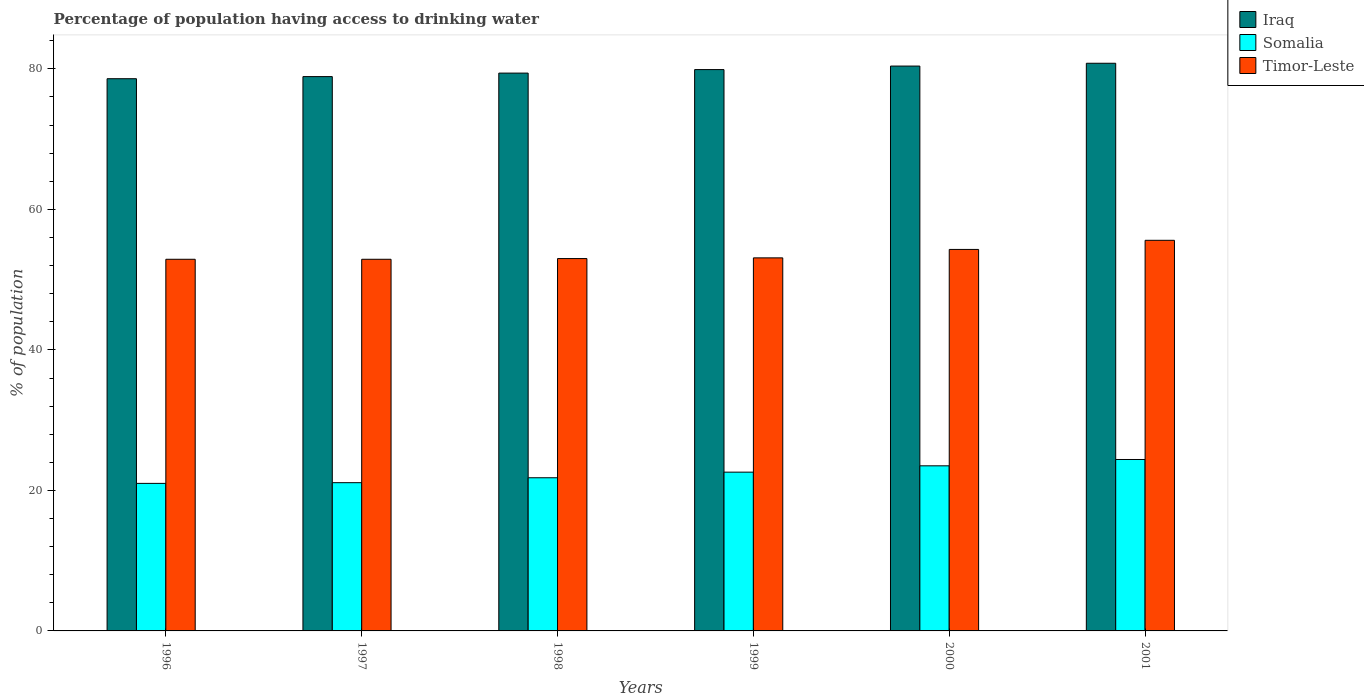How many different coloured bars are there?
Give a very brief answer. 3. How many groups of bars are there?
Ensure brevity in your answer.  6. How many bars are there on the 4th tick from the left?
Make the answer very short. 3. How many bars are there on the 1st tick from the right?
Offer a very short reply. 3. What is the percentage of population having access to drinking water in Somalia in 1998?
Your answer should be compact. 21.8. Across all years, what is the maximum percentage of population having access to drinking water in Iraq?
Offer a very short reply. 80.8. Across all years, what is the minimum percentage of population having access to drinking water in Timor-Leste?
Your answer should be very brief. 52.9. In which year was the percentage of population having access to drinking water in Timor-Leste maximum?
Give a very brief answer. 2001. What is the total percentage of population having access to drinking water in Somalia in the graph?
Offer a very short reply. 134.4. What is the difference between the percentage of population having access to drinking water in Iraq in 1999 and that in 2000?
Give a very brief answer. -0.5. What is the difference between the percentage of population having access to drinking water in Somalia in 2000 and the percentage of population having access to drinking water in Iraq in 1996?
Your answer should be compact. -55.1. What is the average percentage of population having access to drinking water in Timor-Leste per year?
Your answer should be compact. 53.63. In the year 1998, what is the difference between the percentage of population having access to drinking water in Timor-Leste and percentage of population having access to drinking water in Iraq?
Keep it short and to the point. -26.4. In how many years, is the percentage of population having access to drinking water in Timor-Leste greater than 36 %?
Offer a terse response. 6. What is the ratio of the percentage of population having access to drinking water in Somalia in 1998 to that in 2000?
Provide a succinct answer. 0.93. Is the difference between the percentage of population having access to drinking water in Timor-Leste in 1997 and 1999 greater than the difference between the percentage of population having access to drinking water in Iraq in 1997 and 1999?
Your response must be concise. Yes. What is the difference between the highest and the second highest percentage of population having access to drinking water in Timor-Leste?
Give a very brief answer. 1.3. What is the difference between the highest and the lowest percentage of population having access to drinking water in Somalia?
Keep it short and to the point. 3.4. In how many years, is the percentage of population having access to drinking water in Iraq greater than the average percentage of population having access to drinking water in Iraq taken over all years?
Your answer should be compact. 3. Is the sum of the percentage of population having access to drinking water in Timor-Leste in 1996 and 1997 greater than the maximum percentage of population having access to drinking water in Iraq across all years?
Ensure brevity in your answer.  Yes. What does the 1st bar from the left in 1999 represents?
Keep it short and to the point. Iraq. What does the 2nd bar from the right in 1998 represents?
Your response must be concise. Somalia. Is it the case that in every year, the sum of the percentage of population having access to drinking water in Timor-Leste and percentage of population having access to drinking water in Somalia is greater than the percentage of population having access to drinking water in Iraq?
Keep it short and to the point. No. Are all the bars in the graph horizontal?
Provide a short and direct response. No. How many years are there in the graph?
Offer a very short reply. 6. What is the difference between two consecutive major ticks on the Y-axis?
Offer a terse response. 20. Does the graph contain grids?
Provide a short and direct response. No. Where does the legend appear in the graph?
Ensure brevity in your answer.  Top right. How many legend labels are there?
Give a very brief answer. 3. How are the legend labels stacked?
Your answer should be compact. Vertical. What is the title of the graph?
Offer a very short reply. Percentage of population having access to drinking water. What is the label or title of the X-axis?
Make the answer very short. Years. What is the label or title of the Y-axis?
Make the answer very short. % of population. What is the % of population of Iraq in 1996?
Offer a terse response. 78.6. What is the % of population of Timor-Leste in 1996?
Offer a terse response. 52.9. What is the % of population in Iraq in 1997?
Provide a short and direct response. 78.9. What is the % of population of Somalia in 1997?
Make the answer very short. 21.1. What is the % of population in Timor-Leste in 1997?
Provide a short and direct response. 52.9. What is the % of population in Iraq in 1998?
Ensure brevity in your answer.  79.4. What is the % of population in Somalia in 1998?
Offer a terse response. 21.8. What is the % of population of Iraq in 1999?
Your answer should be very brief. 79.9. What is the % of population of Somalia in 1999?
Your response must be concise. 22.6. What is the % of population in Timor-Leste in 1999?
Ensure brevity in your answer.  53.1. What is the % of population of Iraq in 2000?
Offer a terse response. 80.4. What is the % of population of Timor-Leste in 2000?
Ensure brevity in your answer.  54.3. What is the % of population of Iraq in 2001?
Offer a terse response. 80.8. What is the % of population of Somalia in 2001?
Your response must be concise. 24.4. What is the % of population in Timor-Leste in 2001?
Offer a terse response. 55.6. Across all years, what is the maximum % of population of Iraq?
Offer a very short reply. 80.8. Across all years, what is the maximum % of population of Somalia?
Make the answer very short. 24.4. Across all years, what is the maximum % of population in Timor-Leste?
Offer a very short reply. 55.6. Across all years, what is the minimum % of population of Iraq?
Provide a succinct answer. 78.6. Across all years, what is the minimum % of population of Somalia?
Ensure brevity in your answer.  21. Across all years, what is the minimum % of population of Timor-Leste?
Your answer should be compact. 52.9. What is the total % of population of Iraq in the graph?
Ensure brevity in your answer.  478. What is the total % of population of Somalia in the graph?
Your answer should be very brief. 134.4. What is the total % of population in Timor-Leste in the graph?
Make the answer very short. 321.8. What is the difference between the % of population of Timor-Leste in 1996 and that in 1997?
Your answer should be very brief. 0. What is the difference between the % of population of Somalia in 1996 and that in 1998?
Offer a terse response. -0.8. What is the difference between the % of population in Iraq in 1996 and that in 1999?
Ensure brevity in your answer.  -1.3. What is the difference between the % of population of Somalia in 1996 and that in 1999?
Offer a very short reply. -1.6. What is the difference between the % of population of Somalia in 1996 and that in 2000?
Keep it short and to the point. -2.5. What is the difference between the % of population in Timor-Leste in 1996 and that in 2000?
Make the answer very short. -1.4. What is the difference between the % of population in Iraq in 1997 and that in 1998?
Your response must be concise. -0.5. What is the difference between the % of population in Somalia in 1997 and that in 1998?
Offer a very short reply. -0.7. What is the difference between the % of population of Iraq in 1997 and that in 1999?
Your answer should be very brief. -1. What is the difference between the % of population in Timor-Leste in 1997 and that in 1999?
Keep it short and to the point. -0.2. What is the difference between the % of population in Iraq in 1997 and that in 2000?
Ensure brevity in your answer.  -1.5. What is the difference between the % of population of Somalia in 1997 and that in 2000?
Keep it short and to the point. -2.4. What is the difference between the % of population in Somalia in 1997 and that in 2001?
Offer a terse response. -3.3. What is the difference between the % of population of Timor-Leste in 1997 and that in 2001?
Provide a short and direct response. -2.7. What is the difference between the % of population of Iraq in 1998 and that in 1999?
Make the answer very short. -0.5. What is the difference between the % of population in Somalia in 1998 and that in 1999?
Offer a terse response. -0.8. What is the difference between the % of population in Timor-Leste in 1998 and that in 1999?
Make the answer very short. -0.1. What is the difference between the % of population in Somalia in 1998 and that in 2000?
Your answer should be compact. -1.7. What is the difference between the % of population in Timor-Leste in 1998 and that in 2000?
Your answer should be very brief. -1.3. What is the difference between the % of population in Iraq in 1998 and that in 2001?
Your response must be concise. -1.4. What is the difference between the % of population of Somalia in 1998 and that in 2001?
Ensure brevity in your answer.  -2.6. What is the difference between the % of population of Iraq in 1999 and that in 2001?
Ensure brevity in your answer.  -0.9. What is the difference between the % of population of Somalia in 1999 and that in 2001?
Provide a short and direct response. -1.8. What is the difference between the % of population of Timor-Leste in 1999 and that in 2001?
Your answer should be very brief. -2.5. What is the difference between the % of population of Somalia in 2000 and that in 2001?
Offer a very short reply. -0.9. What is the difference between the % of population of Timor-Leste in 2000 and that in 2001?
Offer a very short reply. -1.3. What is the difference between the % of population of Iraq in 1996 and the % of population of Somalia in 1997?
Make the answer very short. 57.5. What is the difference between the % of population of Iraq in 1996 and the % of population of Timor-Leste in 1997?
Keep it short and to the point. 25.7. What is the difference between the % of population of Somalia in 1996 and the % of population of Timor-Leste in 1997?
Make the answer very short. -31.9. What is the difference between the % of population in Iraq in 1996 and the % of population in Somalia in 1998?
Offer a terse response. 56.8. What is the difference between the % of population of Iraq in 1996 and the % of population of Timor-Leste in 1998?
Offer a very short reply. 25.6. What is the difference between the % of population of Somalia in 1996 and the % of population of Timor-Leste in 1998?
Provide a short and direct response. -32. What is the difference between the % of population in Iraq in 1996 and the % of population in Somalia in 1999?
Make the answer very short. 56. What is the difference between the % of population in Somalia in 1996 and the % of population in Timor-Leste in 1999?
Ensure brevity in your answer.  -32.1. What is the difference between the % of population of Iraq in 1996 and the % of population of Somalia in 2000?
Your response must be concise. 55.1. What is the difference between the % of population of Iraq in 1996 and the % of population of Timor-Leste in 2000?
Offer a terse response. 24.3. What is the difference between the % of population in Somalia in 1996 and the % of population in Timor-Leste in 2000?
Provide a short and direct response. -33.3. What is the difference between the % of population in Iraq in 1996 and the % of population in Somalia in 2001?
Provide a succinct answer. 54.2. What is the difference between the % of population in Iraq in 1996 and the % of population in Timor-Leste in 2001?
Offer a very short reply. 23. What is the difference between the % of population of Somalia in 1996 and the % of population of Timor-Leste in 2001?
Offer a very short reply. -34.6. What is the difference between the % of population in Iraq in 1997 and the % of population in Somalia in 1998?
Ensure brevity in your answer.  57.1. What is the difference between the % of population of Iraq in 1997 and the % of population of Timor-Leste in 1998?
Offer a terse response. 25.9. What is the difference between the % of population in Somalia in 1997 and the % of population in Timor-Leste in 1998?
Ensure brevity in your answer.  -31.9. What is the difference between the % of population of Iraq in 1997 and the % of population of Somalia in 1999?
Your answer should be compact. 56.3. What is the difference between the % of population in Iraq in 1997 and the % of population in Timor-Leste in 1999?
Make the answer very short. 25.8. What is the difference between the % of population in Somalia in 1997 and the % of population in Timor-Leste in 1999?
Keep it short and to the point. -32. What is the difference between the % of population in Iraq in 1997 and the % of population in Somalia in 2000?
Ensure brevity in your answer.  55.4. What is the difference between the % of population of Iraq in 1997 and the % of population of Timor-Leste in 2000?
Offer a very short reply. 24.6. What is the difference between the % of population in Somalia in 1997 and the % of population in Timor-Leste in 2000?
Keep it short and to the point. -33.2. What is the difference between the % of population in Iraq in 1997 and the % of population in Somalia in 2001?
Keep it short and to the point. 54.5. What is the difference between the % of population of Iraq in 1997 and the % of population of Timor-Leste in 2001?
Make the answer very short. 23.3. What is the difference between the % of population of Somalia in 1997 and the % of population of Timor-Leste in 2001?
Your response must be concise. -34.5. What is the difference between the % of population of Iraq in 1998 and the % of population of Somalia in 1999?
Offer a terse response. 56.8. What is the difference between the % of population in Iraq in 1998 and the % of population in Timor-Leste in 1999?
Your answer should be very brief. 26.3. What is the difference between the % of population of Somalia in 1998 and the % of population of Timor-Leste in 1999?
Your answer should be very brief. -31.3. What is the difference between the % of population of Iraq in 1998 and the % of population of Somalia in 2000?
Make the answer very short. 55.9. What is the difference between the % of population of Iraq in 1998 and the % of population of Timor-Leste in 2000?
Your response must be concise. 25.1. What is the difference between the % of population of Somalia in 1998 and the % of population of Timor-Leste in 2000?
Provide a short and direct response. -32.5. What is the difference between the % of population of Iraq in 1998 and the % of population of Timor-Leste in 2001?
Give a very brief answer. 23.8. What is the difference between the % of population of Somalia in 1998 and the % of population of Timor-Leste in 2001?
Your response must be concise. -33.8. What is the difference between the % of population in Iraq in 1999 and the % of population in Somalia in 2000?
Give a very brief answer. 56.4. What is the difference between the % of population in Iraq in 1999 and the % of population in Timor-Leste in 2000?
Offer a terse response. 25.6. What is the difference between the % of population of Somalia in 1999 and the % of population of Timor-Leste in 2000?
Provide a short and direct response. -31.7. What is the difference between the % of population in Iraq in 1999 and the % of population in Somalia in 2001?
Provide a succinct answer. 55.5. What is the difference between the % of population of Iraq in 1999 and the % of population of Timor-Leste in 2001?
Make the answer very short. 24.3. What is the difference between the % of population in Somalia in 1999 and the % of population in Timor-Leste in 2001?
Make the answer very short. -33. What is the difference between the % of population of Iraq in 2000 and the % of population of Timor-Leste in 2001?
Offer a terse response. 24.8. What is the difference between the % of population of Somalia in 2000 and the % of population of Timor-Leste in 2001?
Your answer should be very brief. -32.1. What is the average % of population of Iraq per year?
Offer a very short reply. 79.67. What is the average % of population in Somalia per year?
Give a very brief answer. 22.4. What is the average % of population in Timor-Leste per year?
Provide a short and direct response. 53.63. In the year 1996, what is the difference between the % of population of Iraq and % of population of Somalia?
Provide a succinct answer. 57.6. In the year 1996, what is the difference between the % of population of Iraq and % of population of Timor-Leste?
Your answer should be very brief. 25.7. In the year 1996, what is the difference between the % of population in Somalia and % of population in Timor-Leste?
Give a very brief answer. -31.9. In the year 1997, what is the difference between the % of population in Iraq and % of population in Somalia?
Provide a succinct answer. 57.8. In the year 1997, what is the difference between the % of population of Somalia and % of population of Timor-Leste?
Ensure brevity in your answer.  -31.8. In the year 1998, what is the difference between the % of population in Iraq and % of population in Somalia?
Ensure brevity in your answer.  57.6. In the year 1998, what is the difference between the % of population in Iraq and % of population in Timor-Leste?
Ensure brevity in your answer.  26.4. In the year 1998, what is the difference between the % of population in Somalia and % of population in Timor-Leste?
Your answer should be compact. -31.2. In the year 1999, what is the difference between the % of population of Iraq and % of population of Somalia?
Offer a terse response. 57.3. In the year 1999, what is the difference between the % of population of Iraq and % of population of Timor-Leste?
Your response must be concise. 26.8. In the year 1999, what is the difference between the % of population of Somalia and % of population of Timor-Leste?
Make the answer very short. -30.5. In the year 2000, what is the difference between the % of population in Iraq and % of population in Somalia?
Offer a very short reply. 56.9. In the year 2000, what is the difference between the % of population in Iraq and % of population in Timor-Leste?
Give a very brief answer. 26.1. In the year 2000, what is the difference between the % of population in Somalia and % of population in Timor-Leste?
Offer a very short reply. -30.8. In the year 2001, what is the difference between the % of population in Iraq and % of population in Somalia?
Ensure brevity in your answer.  56.4. In the year 2001, what is the difference between the % of population of Iraq and % of population of Timor-Leste?
Keep it short and to the point. 25.2. In the year 2001, what is the difference between the % of population in Somalia and % of population in Timor-Leste?
Give a very brief answer. -31.2. What is the ratio of the % of population of Timor-Leste in 1996 to that in 1997?
Your response must be concise. 1. What is the ratio of the % of population of Iraq in 1996 to that in 1998?
Make the answer very short. 0.99. What is the ratio of the % of population in Somalia in 1996 to that in 1998?
Offer a very short reply. 0.96. What is the ratio of the % of population of Iraq in 1996 to that in 1999?
Provide a succinct answer. 0.98. What is the ratio of the % of population of Somalia in 1996 to that in 1999?
Provide a succinct answer. 0.93. What is the ratio of the % of population of Timor-Leste in 1996 to that in 1999?
Provide a succinct answer. 1. What is the ratio of the % of population of Iraq in 1996 to that in 2000?
Offer a very short reply. 0.98. What is the ratio of the % of population of Somalia in 1996 to that in 2000?
Offer a terse response. 0.89. What is the ratio of the % of population in Timor-Leste in 1996 to that in 2000?
Keep it short and to the point. 0.97. What is the ratio of the % of population in Iraq in 1996 to that in 2001?
Your answer should be compact. 0.97. What is the ratio of the % of population of Somalia in 1996 to that in 2001?
Give a very brief answer. 0.86. What is the ratio of the % of population in Timor-Leste in 1996 to that in 2001?
Provide a succinct answer. 0.95. What is the ratio of the % of population in Iraq in 1997 to that in 1998?
Keep it short and to the point. 0.99. What is the ratio of the % of population of Somalia in 1997 to that in 1998?
Your answer should be compact. 0.97. What is the ratio of the % of population of Timor-Leste in 1997 to that in 1998?
Provide a succinct answer. 1. What is the ratio of the % of population of Iraq in 1997 to that in 1999?
Make the answer very short. 0.99. What is the ratio of the % of population in Somalia in 1997 to that in 1999?
Your response must be concise. 0.93. What is the ratio of the % of population of Timor-Leste in 1997 to that in 1999?
Give a very brief answer. 1. What is the ratio of the % of population in Iraq in 1997 to that in 2000?
Your answer should be very brief. 0.98. What is the ratio of the % of population of Somalia in 1997 to that in 2000?
Your answer should be very brief. 0.9. What is the ratio of the % of population in Timor-Leste in 1997 to that in 2000?
Your answer should be very brief. 0.97. What is the ratio of the % of population of Iraq in 1997 to that in 2001?
Your answer should be very brief. 0.98. What is the ratio of the % of population of Somalia in 1997 to that in 2001?
Provide a succinct answer. 0.86. What is the ratio of the % of population in Timor-Leste in 1997 to that in 2001?
Your answer should be compact. 0.95. What is the ratio of the % of population in Iraq in 1998 to that in 1999?
Offer a very short reply. 0.99. What is the ratio of the % of population of Somalia in 1998 to that in 1999?
Your answer should be very brief. 0.96. What is the ratio of the % of population in Iraq in 1998 to that in 2000?
Provide a short and direct response. 0.99. What is the ratio of the % of population of Somalia in 1998 to that in 2000?
Your answer should be compact. 0.93. What is the ratio of the % of population of Timor-Leste in 1998 to that in 2000?
Offer a terse response. 0.98. What is the ratio of the % of population of Iraq in 1998 to that in 2001?
Give a very brief answer. 0.98. What is the ratio of the % of population in Somalia in 1998 to that in 2001?
Offer a terse response. 0.89. What is the ratio of the % of population in Timor-Leste in 1998 to that in 2001?
Provide a succinct answer. 0.95. What is the ratio of the % of population of Somalia in 1999 to that in 2000?
Provide a succinct answer. 0.96. What is the ratio of the % of population in Timor-Leste in 1999 to that in 2000?
Provide a succinct answer. 0.98. What is the ratio of the % of population of Iraq in 1999 to that in 2001?
Your answer should be compact. 0.99. What is the ratio of the % of population of Somalia in 1999 to that in 2001?
Provide a succinct answer. 0.93. What is the ratio of the % of population of Timor-Leste in 1999 to that in 2001?
Your answer should be compact. 0.95. What is the ratio of the % of population in Somalia in 2000 to that in 2001?
Your response must be concise. 0.96. What is the ratio of the % of population in Timor-Leste in 2000 to that in 2001?
Your response must be concise. 0.98. What is the difference between the highest and the second highest % of population of Iraq?
Provide a succinct answer. 0.4. What is the difference between the highest and the lowest % of population in Somalia?
Keep it short and to the point. 3.4. What is the difference between the highest and the lowest % of population of Timor-Leste?
Your response must be concise. 2.7. 